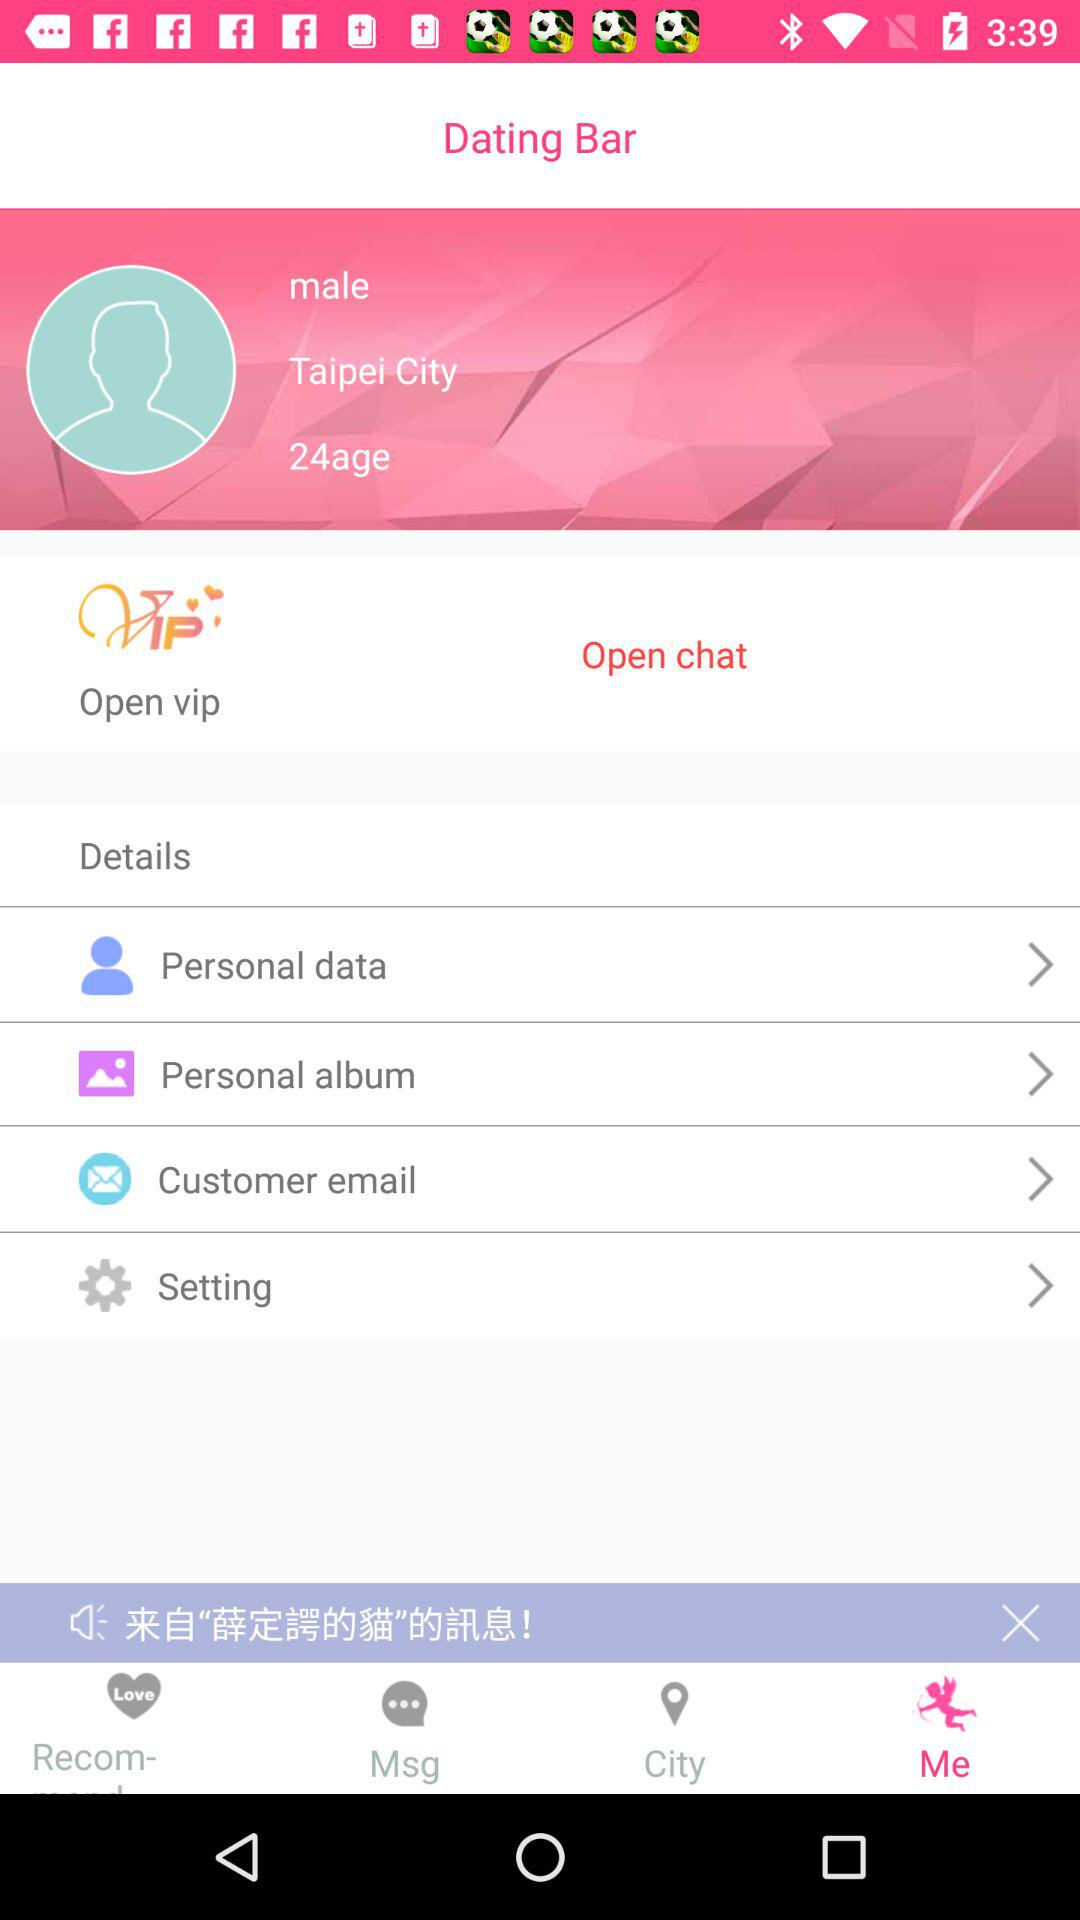What is the age of the user? The age of the user is 24 years. 